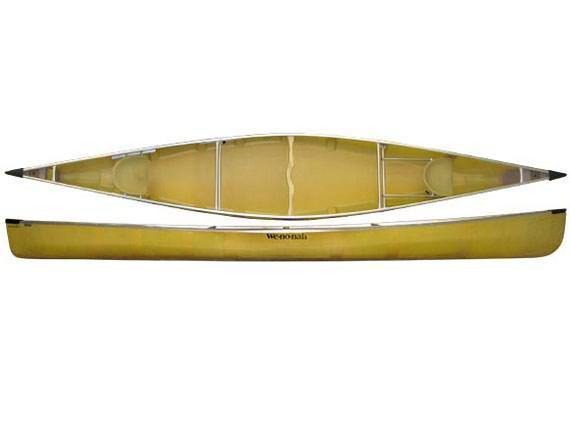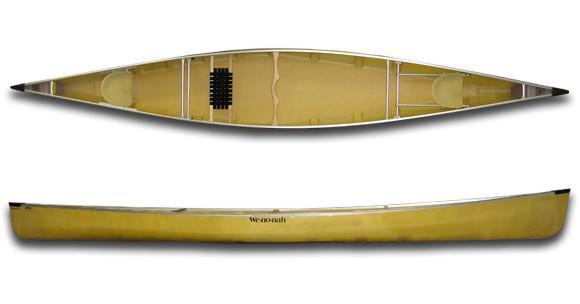The first image is the image on the left, the second image is the image on the right. For the images shown, is this caption "Both images show two views of a yellow-bodied canoe, and one features at least one woven black seat inside the canoe." true? Answer yes or no. Yes. The first image is the image on the left, the second image is the image on the right. Given the left and right images, does the statement "There is one canoe in each image, and they are all the same color inside as out." hold true? Answer yes or no. Yes. 